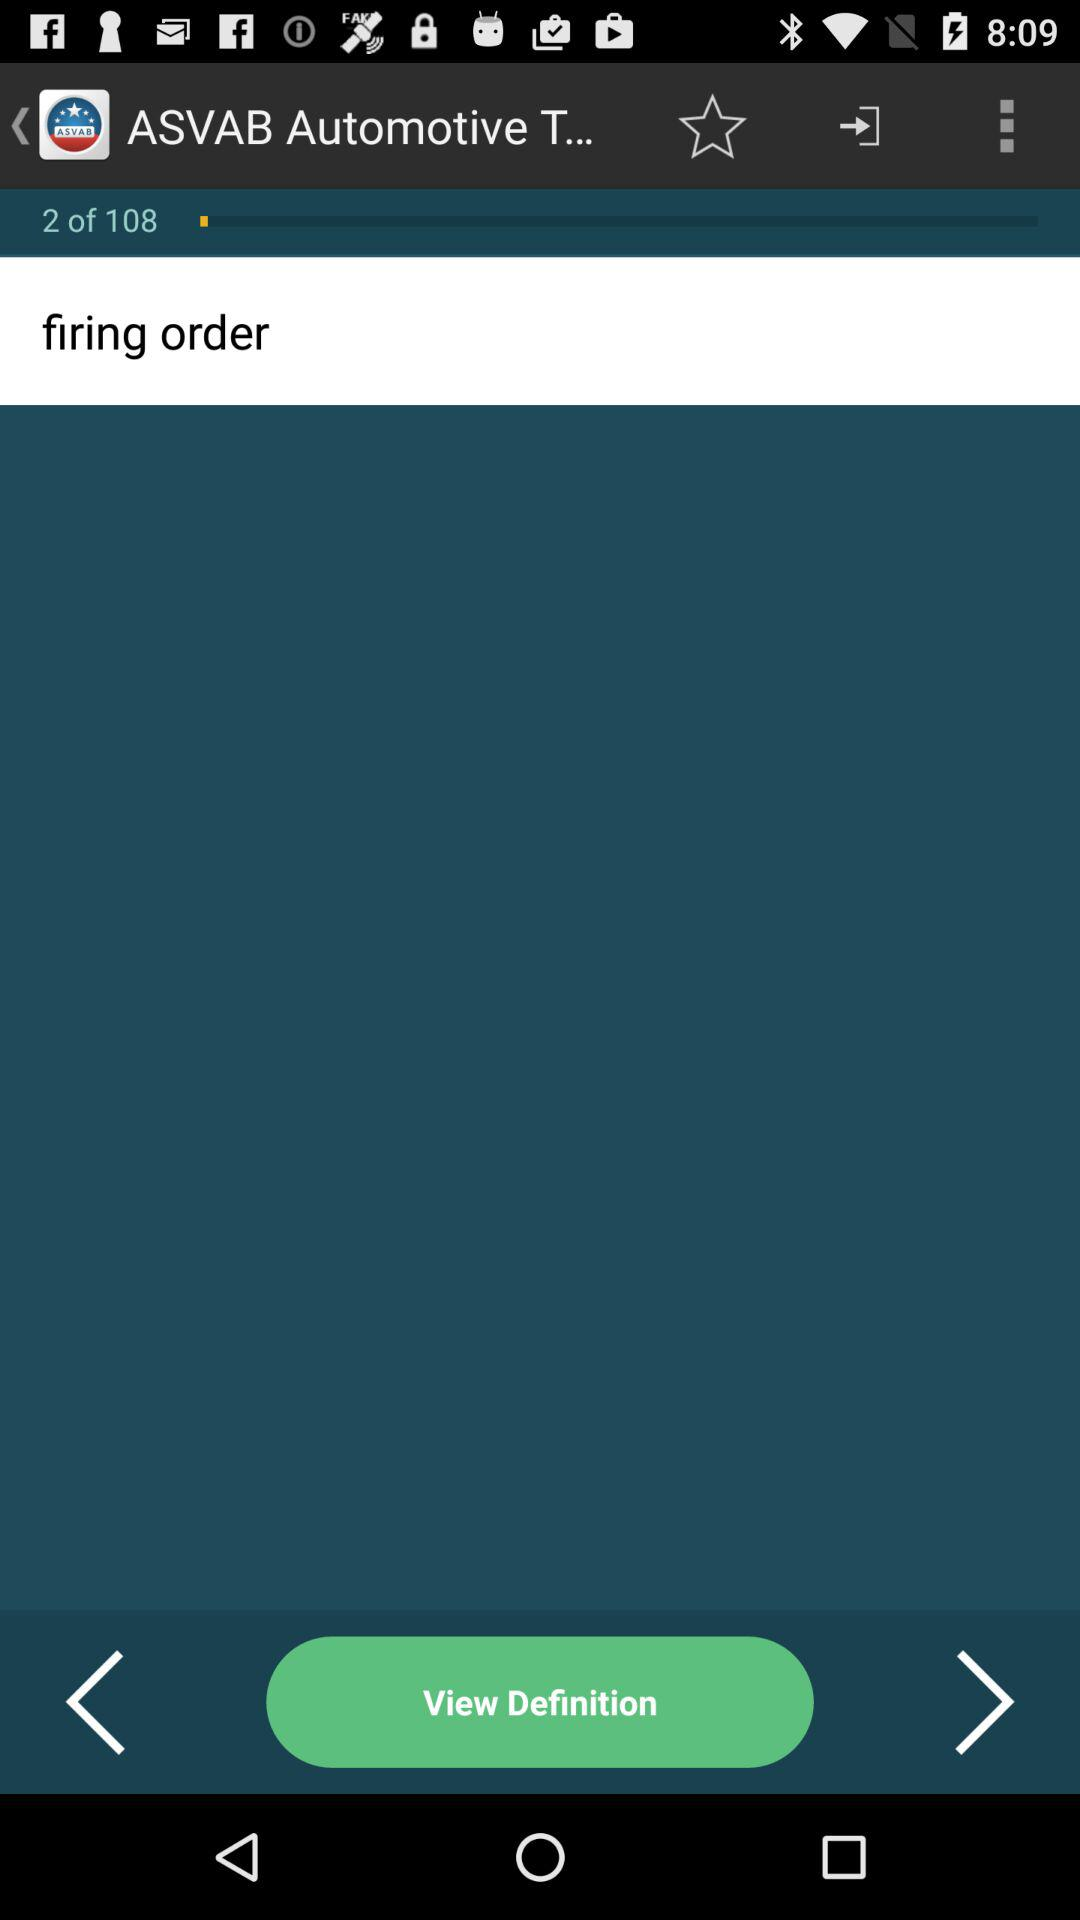What stage am I on? You are on stage 2. 